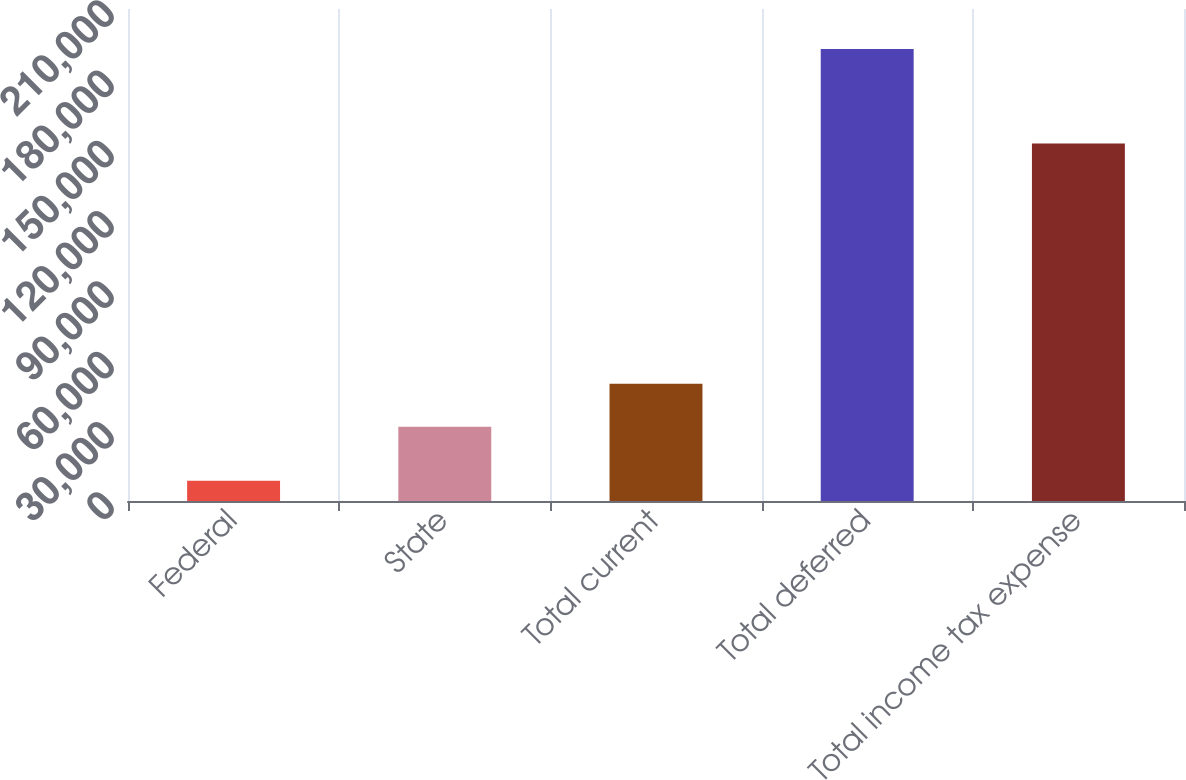Convert chart to OTSL. <chart><loc_0><loc_0><loc_500><loc_500><bar_chart><fcel>Federal<fcel>State<fcel>Total current<fcel>Total deferred<fcel>Total income tax expense<nl><fcel>8667<fcel>31673<fcel>50097.7<fcel>192914<fcel>152574<nl></chart> 